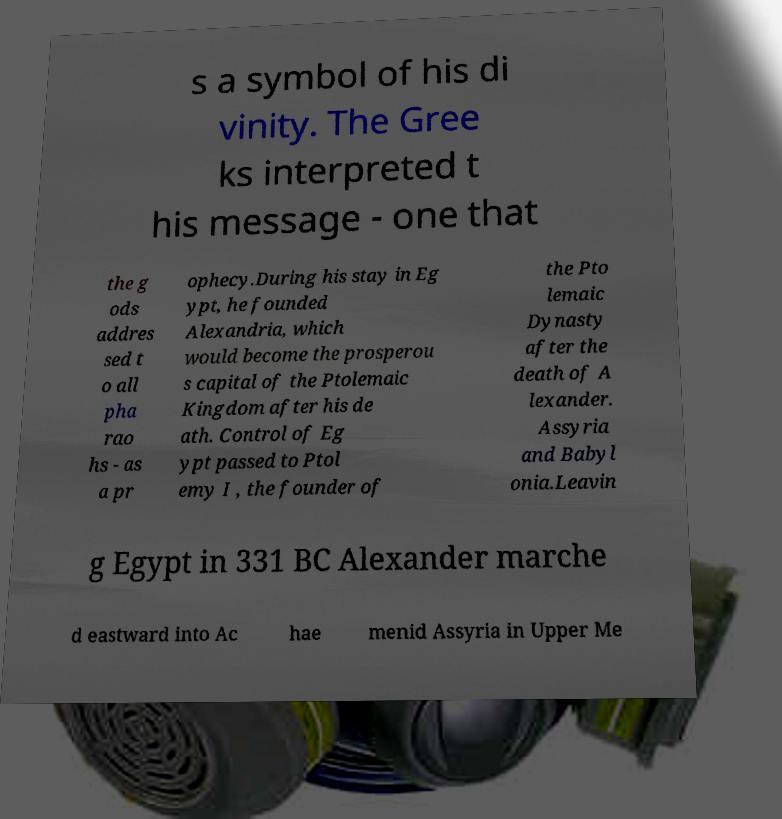Please read and relay the text visible in this image. What does it say? s a symbol of his di vinity. The Gree ks interpreted t his message - one that the g ods addres sed t o all pha rao hs - as a pr ophecy.During his stay in Eg ypt, he founded Alexandria, which would become the prosperou s capital of the Ptolemaic Kingdom after his de ath. Control of Eg ypt passed to Ptol emy I , the founder of the Pto lemaic Dynasty after the death of A lexander. Assyria and Babyl onia.Leavin g Egypt in 331 BC Alexander marche d eastward into Ac hae menid Assyria in Upper Me 